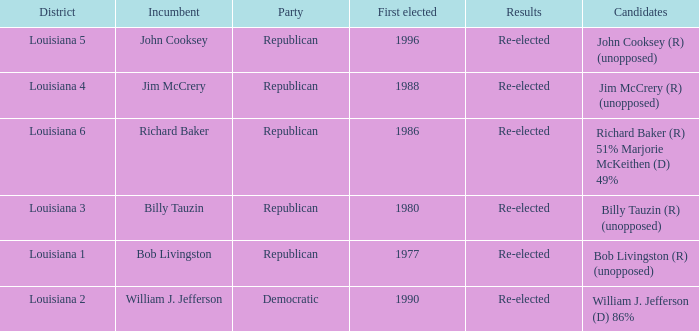What party does William J. Jefferson? Democratic. 